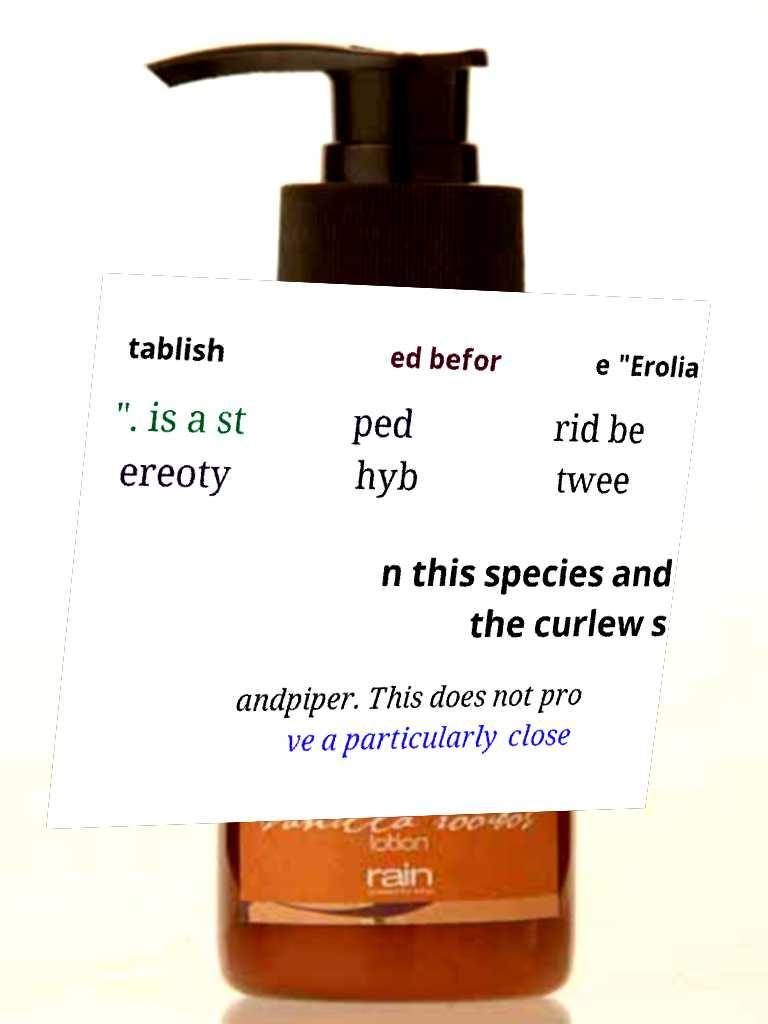Please read and relay the text visible in this image. What does it say? tablish ed befor e "Erolia ". is a st ereoty ped hyb rid be twee n this species and the curlew s andpiper. This does not pro ve a particularly close 